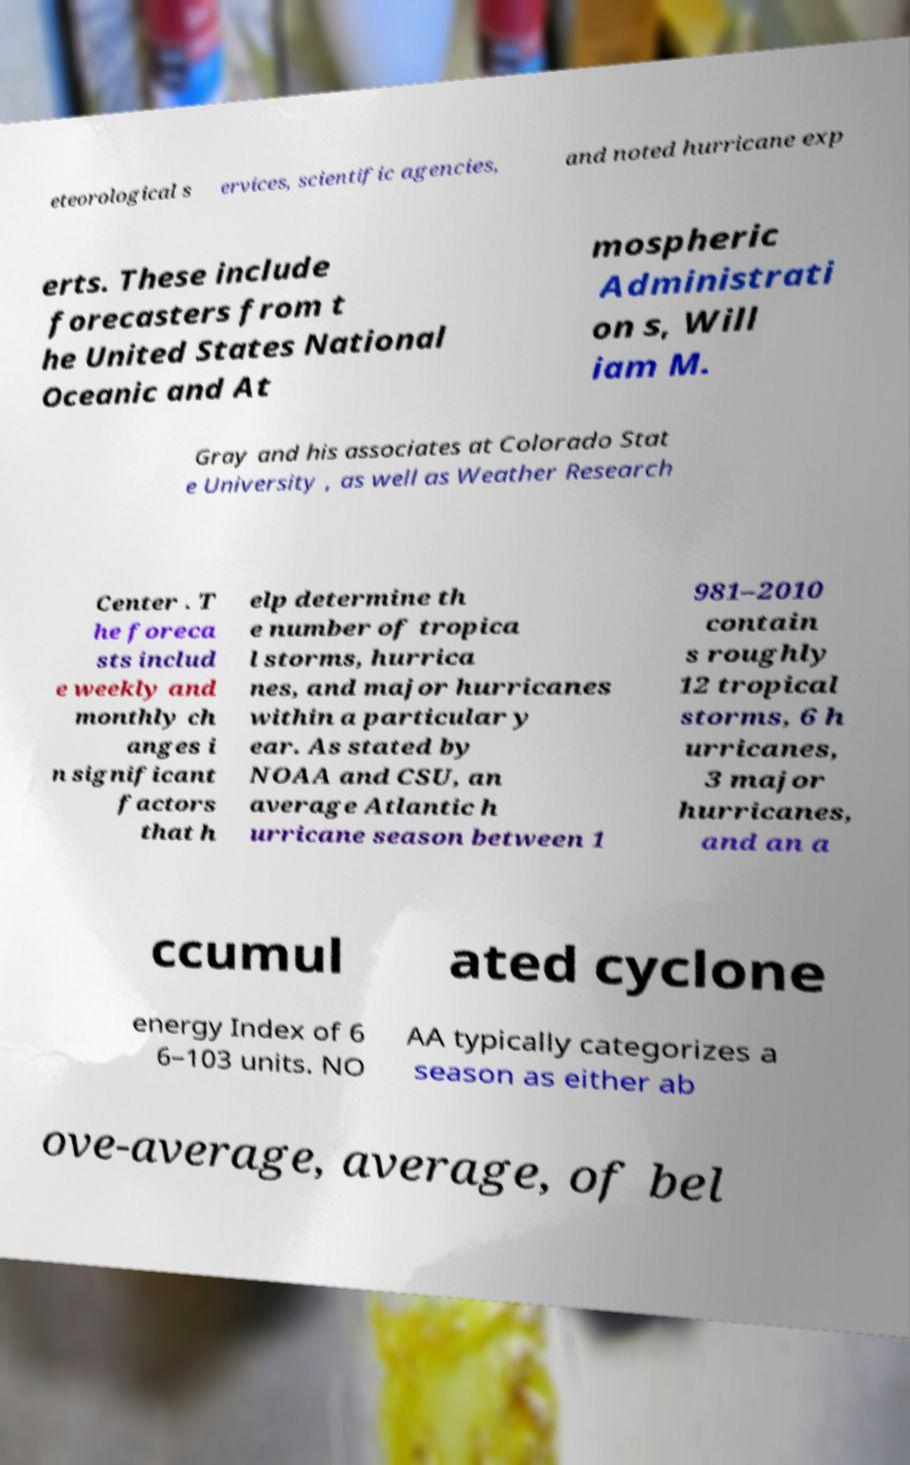There's text embedded in this image that I need extracted. Can you transcribe it verbatim? eteorological s ervices, scientific agencies, and noted hurricane exp erts. These include forecasters from t he United States National Oceanic and At mospheric Administrati on s, Will iam M. Gray and his associates at Colorado Stat e University , as well as Weather Research Center . T he foreca sts includ e weekly and monthly ch anges i n significant factors that h elp determine th e number of tropica l storms, hurrica nes, and major hurricanes within a particular y ear. As stated by NOAA and CSU, an average Atlantic h urricane season between 1 981–2010 contain s roughly 12 tropical storms, 6 h urricanes, 3 major hurricanes, and an a ccumul ated cyclone energy Index of 6 6–103 units. NO AA typically categorizes a season as either ab ove-average, average, of bel 